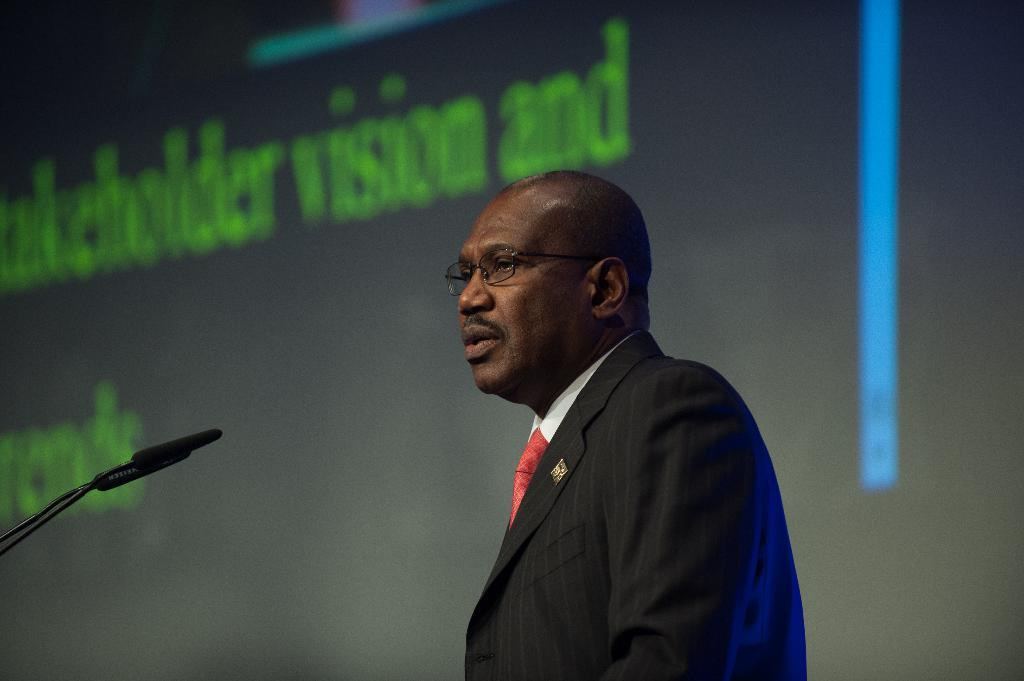What is the appearance of the man in the image? The man in the image is bald-headed. What is the man wearing in the image? The man is wearing a black suit. What is the man doing in the image? The man is talking on a microphone. What can be seen in the background of the image? There is a screen visible in the background. Can you see any horns on the man in the image? No, there are no horns visible on the man in the image. Are there any dinosaurs present in the image? No, there are no dinosaurs present in the image. 